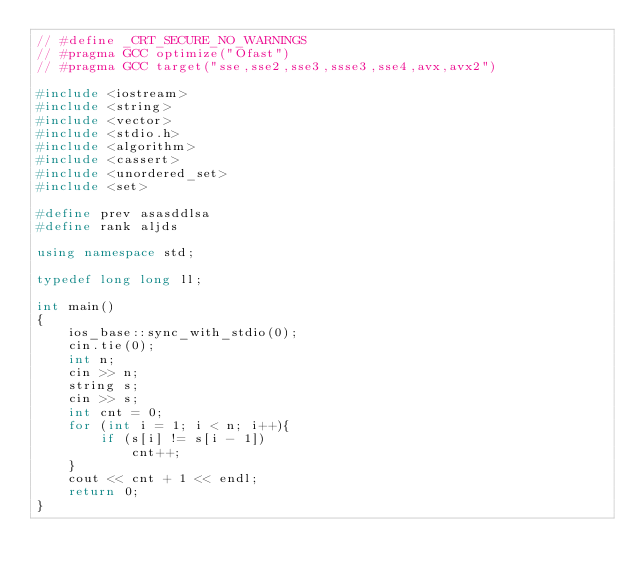Convert code to text. <code><loc_0><loc_0><loc_500><loc_500><_C++_>// #define _CRT_SECURE_NO_WARNINGS
// #pragma GCC optimize("Ofast")
// #pragma GCC target("sse,sse2,sse3,ssse3,sse4,avx,avx2")

#include <iostream>
#include <string>
#include <vector>
#include <stdio.h>
#include <algorithm>
#include <cassert>
#include <unordered_set>
#include <set>

#define prev asasddlsa
#define rank aljds

using namespace std;

typedef long long ll;

int main()
{
    ios_base::sync_with_stdio(0);
    cin.tie(0);
    int n;
    cin >> n;
    string s;
    cin >> s;
    int cnt = 0;
    for (int i = 1; i < n; i++){
        if (s[i] != s[i - 1])
            cnt++;
    }
    cout << cnt + 1 << endl;
    return 0;
}</code> 